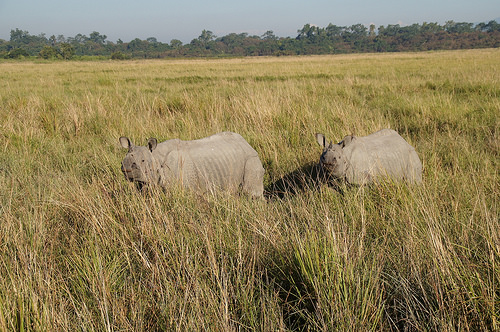<image>
Can you confirm if the rhino is on the grass? Yes. Looking at the image, I can see the rhino is positioned on top of the grass, with the grass providing support. 